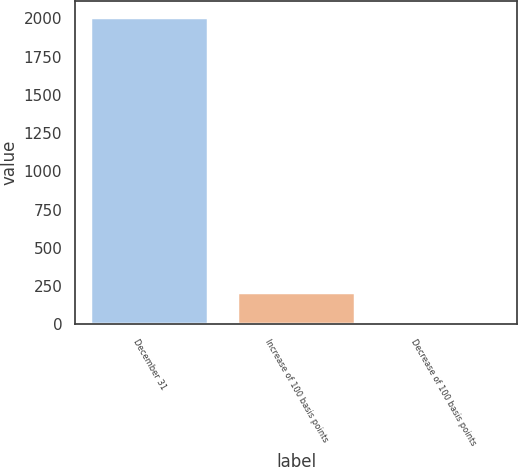<chart> <loc_0><loc_0><loc_500><loc_500><bar_chart><fcel>December 31<fcel>Increase of 100 basis points<fcel>Decrease of 100 basis points<nl><fcel>2012<fcel>210.2<fcel>10<nl></chart> 